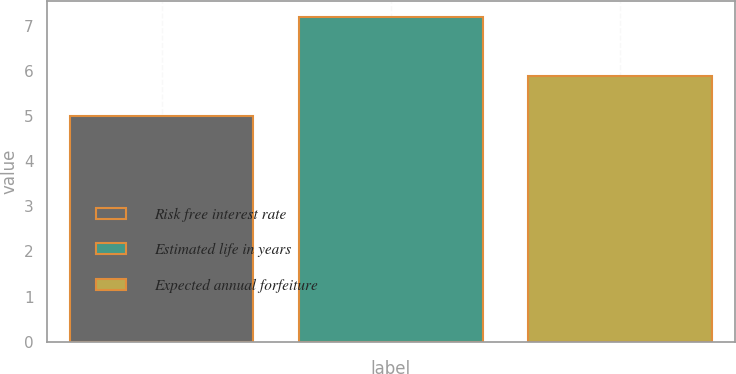<chart> <loc_0><loc_0><loc_500><loc_500><bar_chart><fcel>Risk free interest rate<fcel>Estimated life in years<fcel>Expected annual forfeiture<nl><fcel>5<fcel>7.2<fcel>5.9<nl></chart> 